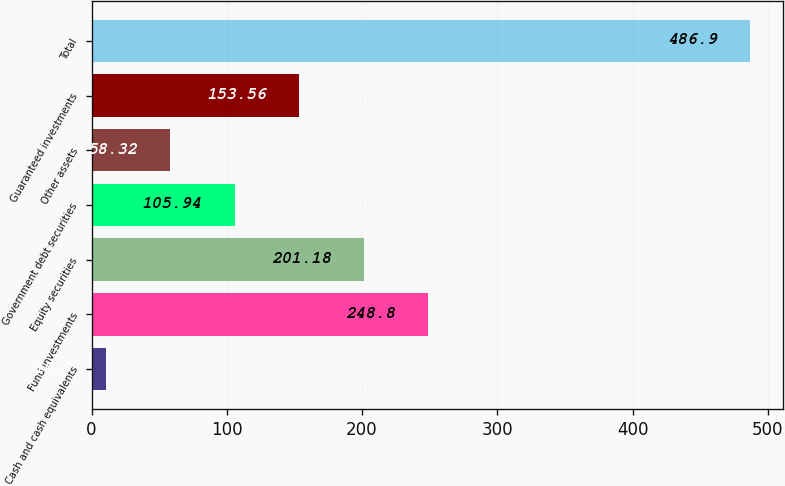<chart> <loc_0><loc_0><loc_500><loc_500><bar_chart><fcel>Cash and cash equivalents<fcel>Fund investments<fcel>Equity securities<fcel>Government debt securities<fcel>Other assets<fcel>Guaranteed investments<fcel>Total<nl><fcel>10.7<fcel>248.8<fcel>201.18<fcel>105.94<fcel>58.32<fcel>153.56<fcel>486.9<nl></chart> 